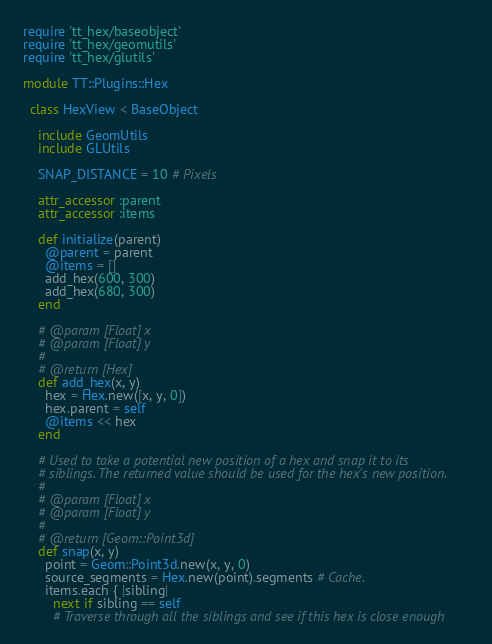<code> <loc_0><loc_0><loc_500><loc_500><_Ruby_>require 'tt_hex/baseobject'
require 'tt_hex/geomutils'
require 'tt_hex/glutils'

module TT::Plugins::Hex

  class HexView < BaseObject

    include GeomUtils
    include GLUtils

    SNAP_DISTANCE = 10 # Pixels

    attr_accessor :parent
    attr_accessor :items

    def initialize(parent)
      @parent = parent
      @items = []
      add_hex(600, 300)
      add_hex(680, 300)
    end

    # @param [Float] x
    # @param [Float] y
    #
    # @return [Hex]
    def add_hex(x, y)
      hex = Hex.new([x, y, 0])
      hex.parent = self
      @items << hex
    end

    # Used to take a potential new position of a hex and snap it to its
    # siblings. The returned value should be used for the hex's new position.
    #
    # @param [Float] x
    # @param [Float] y
    #
    # @return [Geom::Point3d]
    def snap(x, y)
      point = Geom::Point3d.new(x, y, 0)
      source_segments = Hex.new(point).segments # Cache.
      items.each { |sibling|
        next if sibling == self
        # Traverse through all the siblings and see if this hex is close enough</code> 